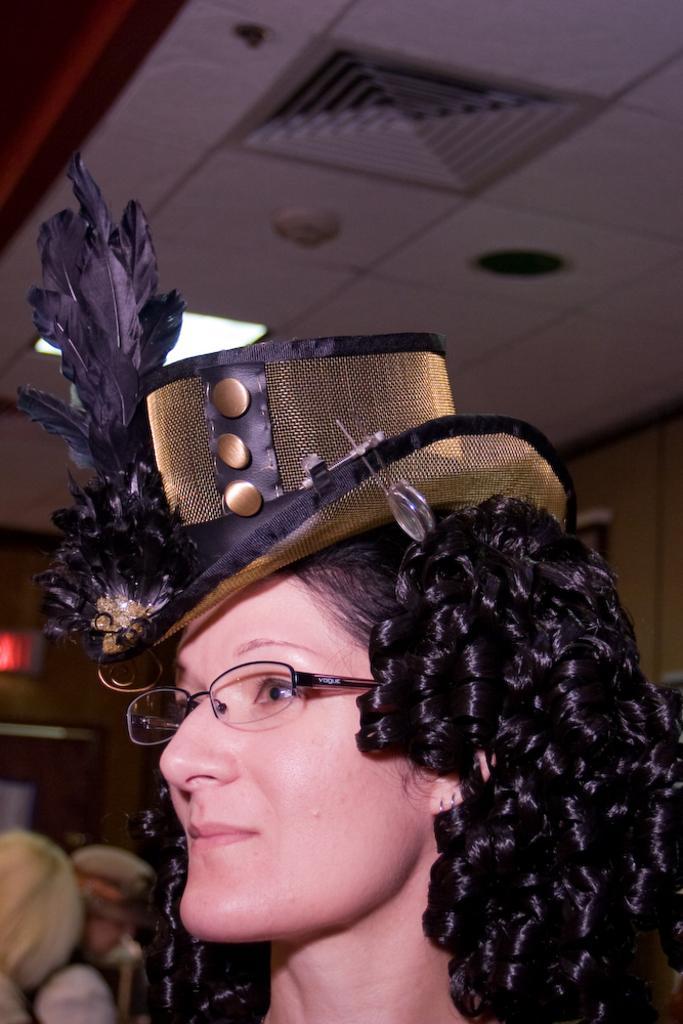In one or two sentences, can you explain what this image depicts? In the picture there is a woman, she has a curly hair she is wearing a hat and there are some feathers kept on the hat and the background of the women is blur. 